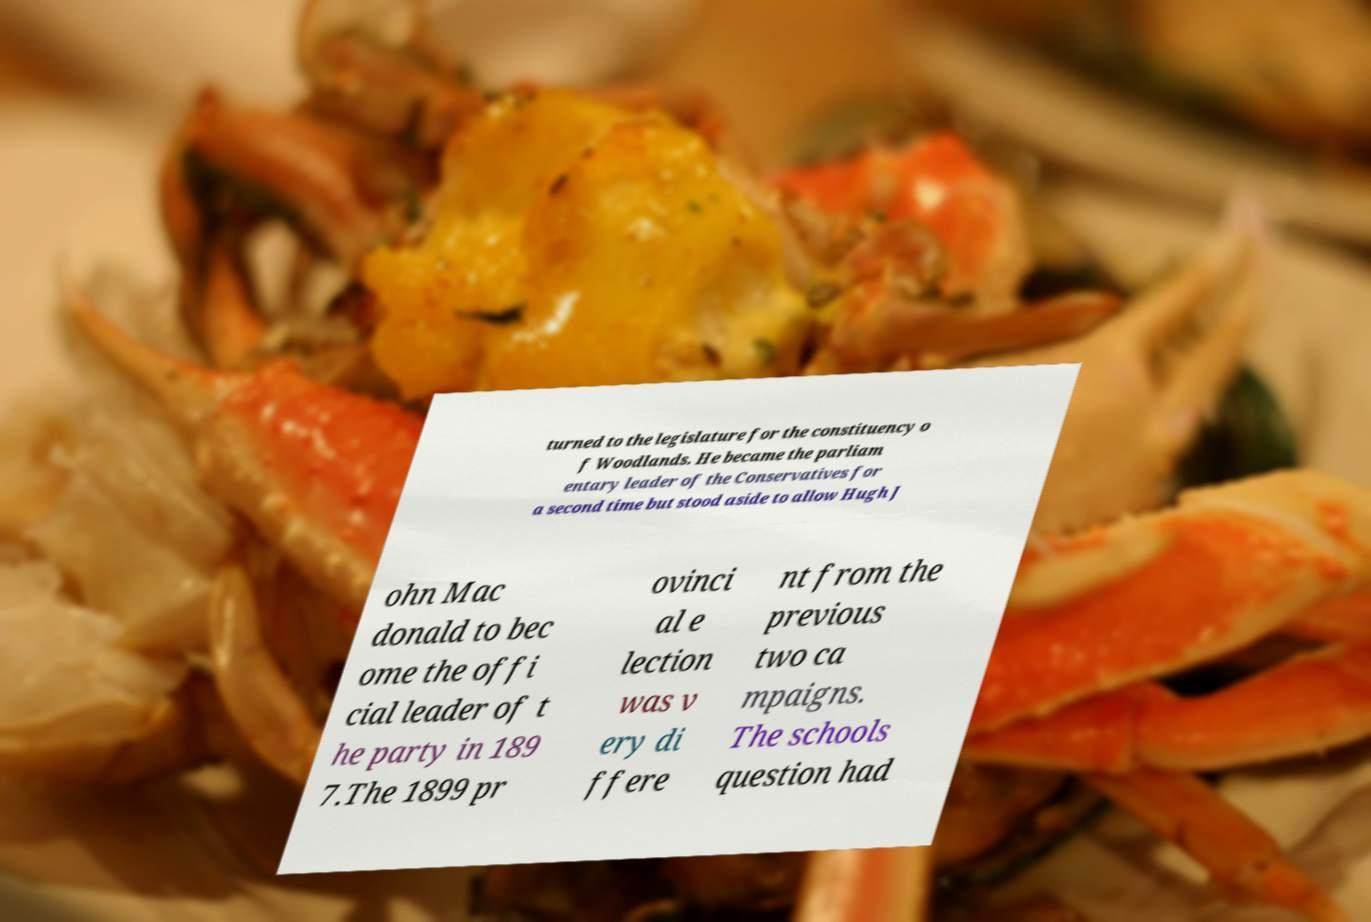Could you extract and type out the text from this image? turned to the legislature for the constituency o f Woodlands. He became the parliam entary leader of the Conservatives for a second time but stood aside to allow Hugh J ohn Mac donald to bec ome the offi cial leader of t he party in 189 7.The 1899 pr ovinci al e lection was v ery di ffere nt from the previous two ca mpaigns. The schools question had 